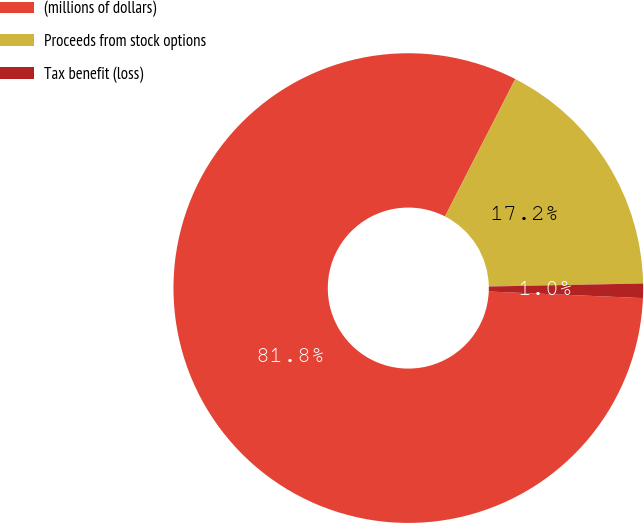Convert chart to OTSL. <chart><loc_0><loc_0><loc_500><loc_500><pie_chart><fcel>(millions of dollars)<fcel>Proceeds from stock options<fcel>Tax benefit (loss)<nl><fcel>81.84%<fcel>17.16%<fcel>0.99%<nl></chart> 